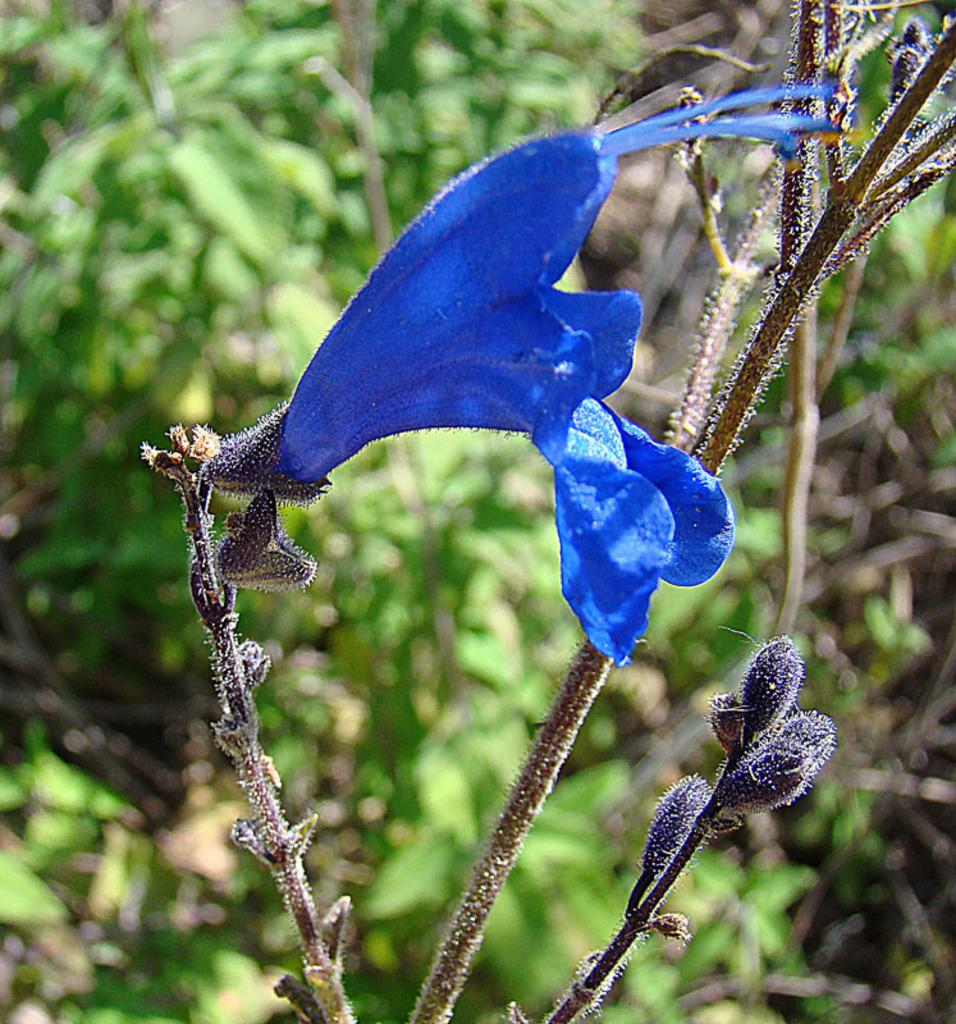What type of plant is visible in the image? There is a flower in the image. Are there any other plants present in the image? Yes, there are plants in the image. Can you describe the background of the image? The background of the image is blurred. How many secretaries are visible in the image? There are no secretaries present in the image; it features a flower and other plants. What type of pen is being used by the crowd in the image? There is no crowd or pen present in the image. 